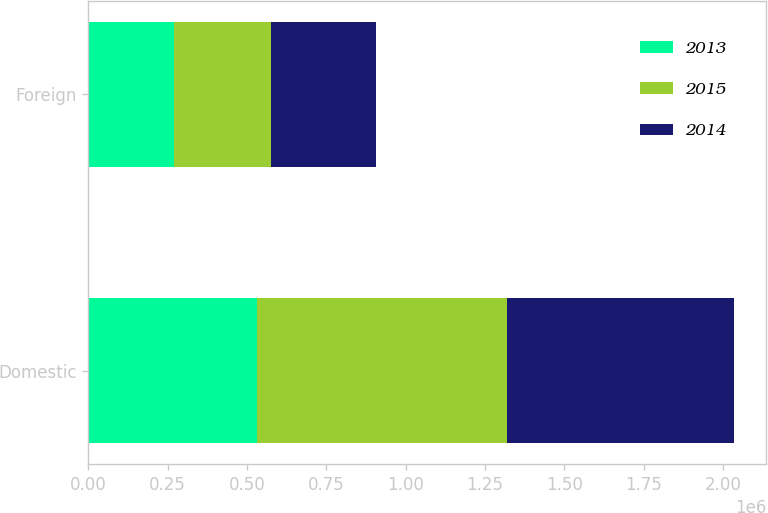Convert chart. <chart><loc_0><loc_0><loc_500><loc_500><stacked_bar_chart><ecel><fcel>Domestic<fcel>Foreign<nl><fcel>2013<fcel>530268<fcel>270342<nl><fcel>2015<fcel>789689<fcel>304518<nl><fcel>2014<fcel>714723<fcel>331263<nl></chart> 